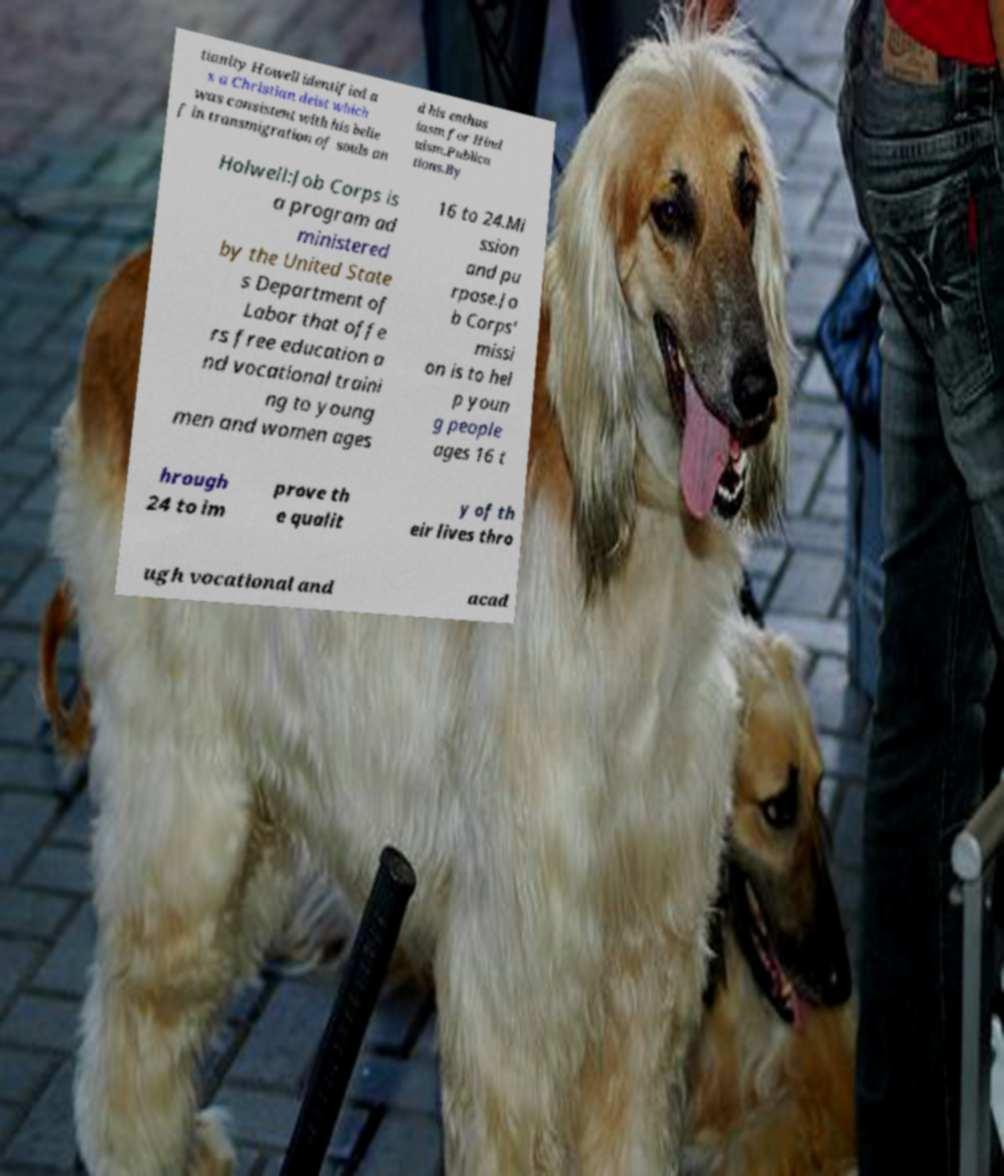What messages or text are displayed in this image? I need them in a readable, typed format. tianity Howell identified a s a Christian deist which was consistent with his belie f in transmigration of souls an d his enthus iasm for Hind uism.Publica tions.By Holwell:Job Corps is a program ad ministered by the United State s Department of Labor that offe rs free education a nd vocational traini ng to young men and women ages 16 to 24.Mi ssion and pu rpose.Jo b Corps' missi on is to hel p youn g people ages 16 t hrough 24 to im prove th e qualit y of th eir lives thro ugh vocational and acad 